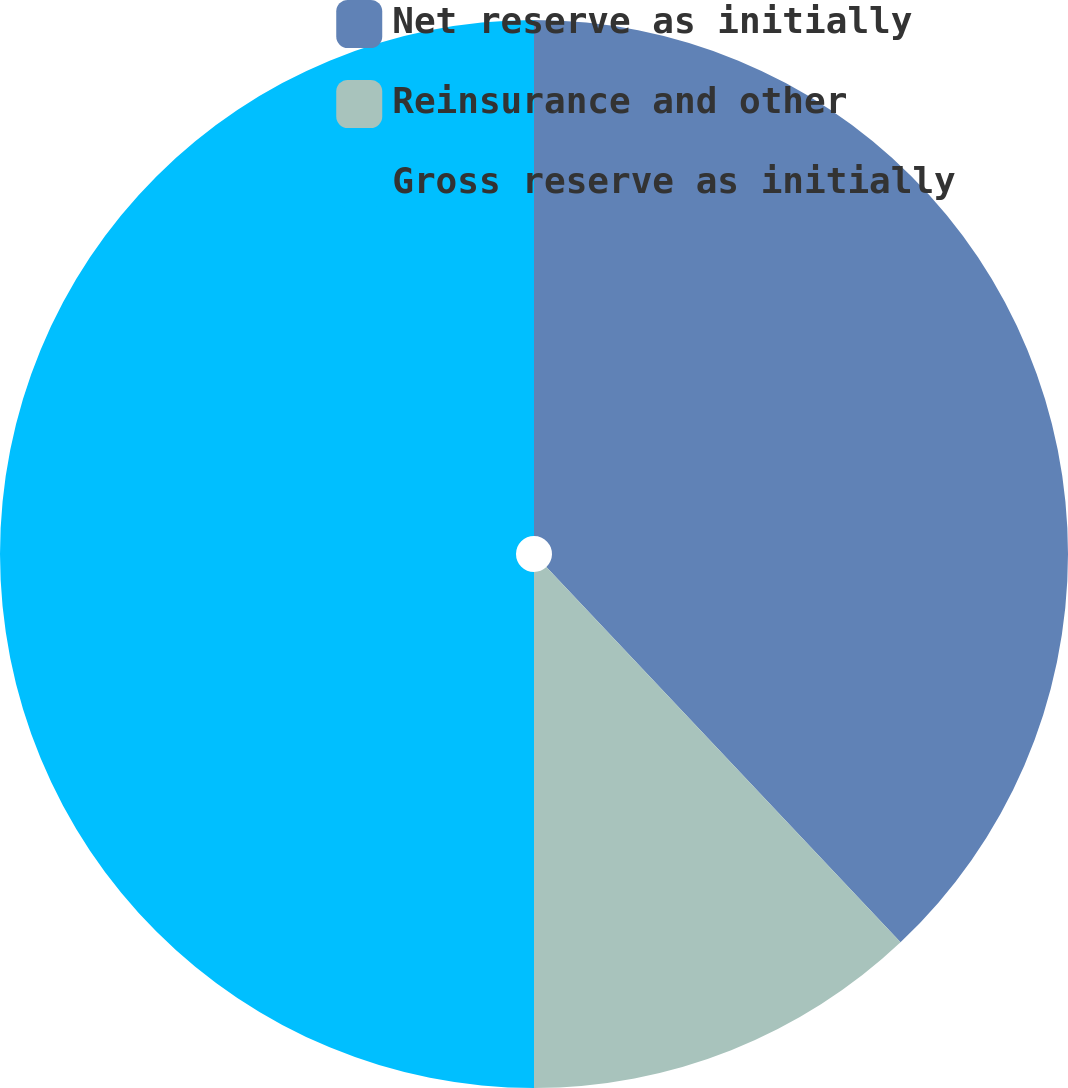<chart> <loc_0><loc_0><loc_500><loc_500><pie_chart><fcel>Net reserve as initially<fcel>Reinsurance and other<fcel>Gross reserve as initially<nl><fcel>37.96%<fcel>12.04%<fcel>50.0%<nl></chart> 